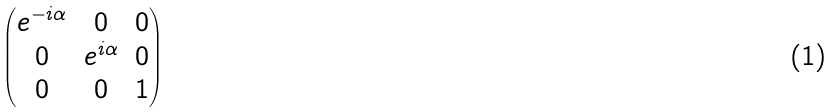<formula> <loc_0><loc_0><loc_500><loc_500>\begin{pmatrix} e ^ { - i \alpha } & 0 & 0 \\ 0 & e ^ { i \alpha } & 0 \\ 0 & 0 & 1 \end{pmatrix}</formula> 